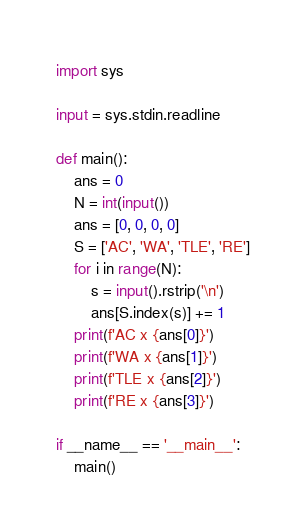<code> <loc_0><loc_0><loc_500><loc_500><_Python_>import sys

input = sys.stdin.readline

def main():
    ans = 0
    N = int(input())
    ans = [0, 0, 0, 0]
    S = ['AC', 'WA', 'TLE', 'RE']
    for i in range(N):
        s = input().rstrip('\n')
        ans[S.index(s)] += 1
    print(f'AC x {ans[0]}')
    print(f'WA x {ans[1]}')
    print(f'TLE x {ans[2]}')
    print(f'RE x {ans[3]}')

if __name__ == '__main__':
    main()</code> 